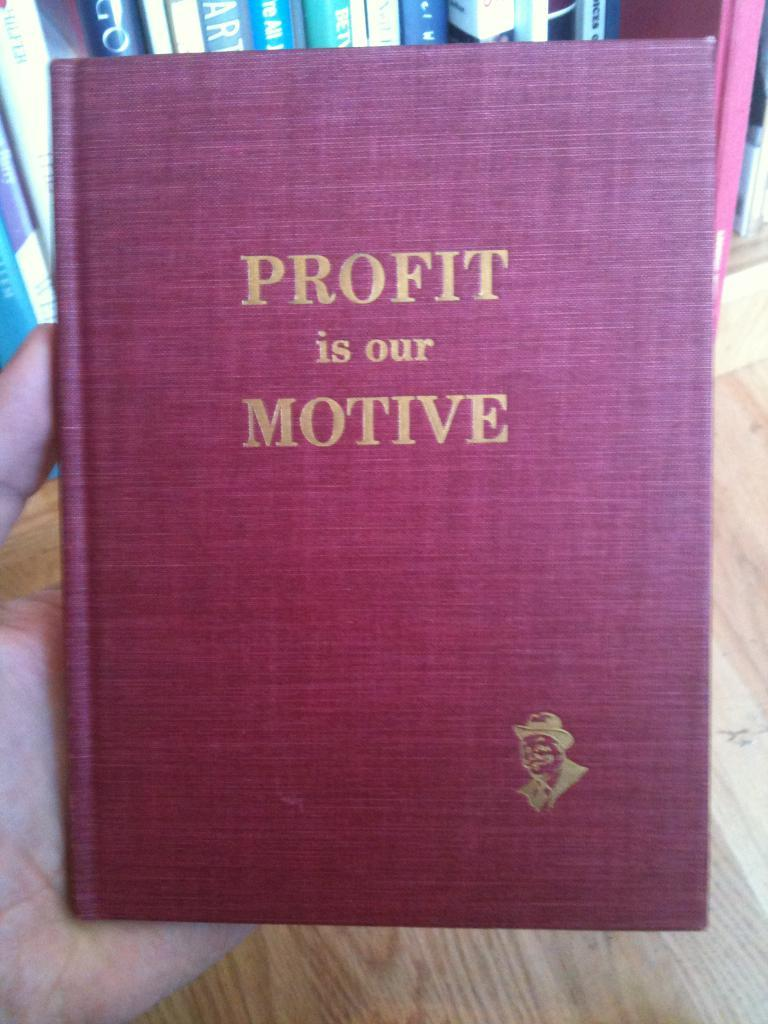<image>
Present a compact description of the photo's key features. Someone is holding a book that says "Profit is our Motive." 